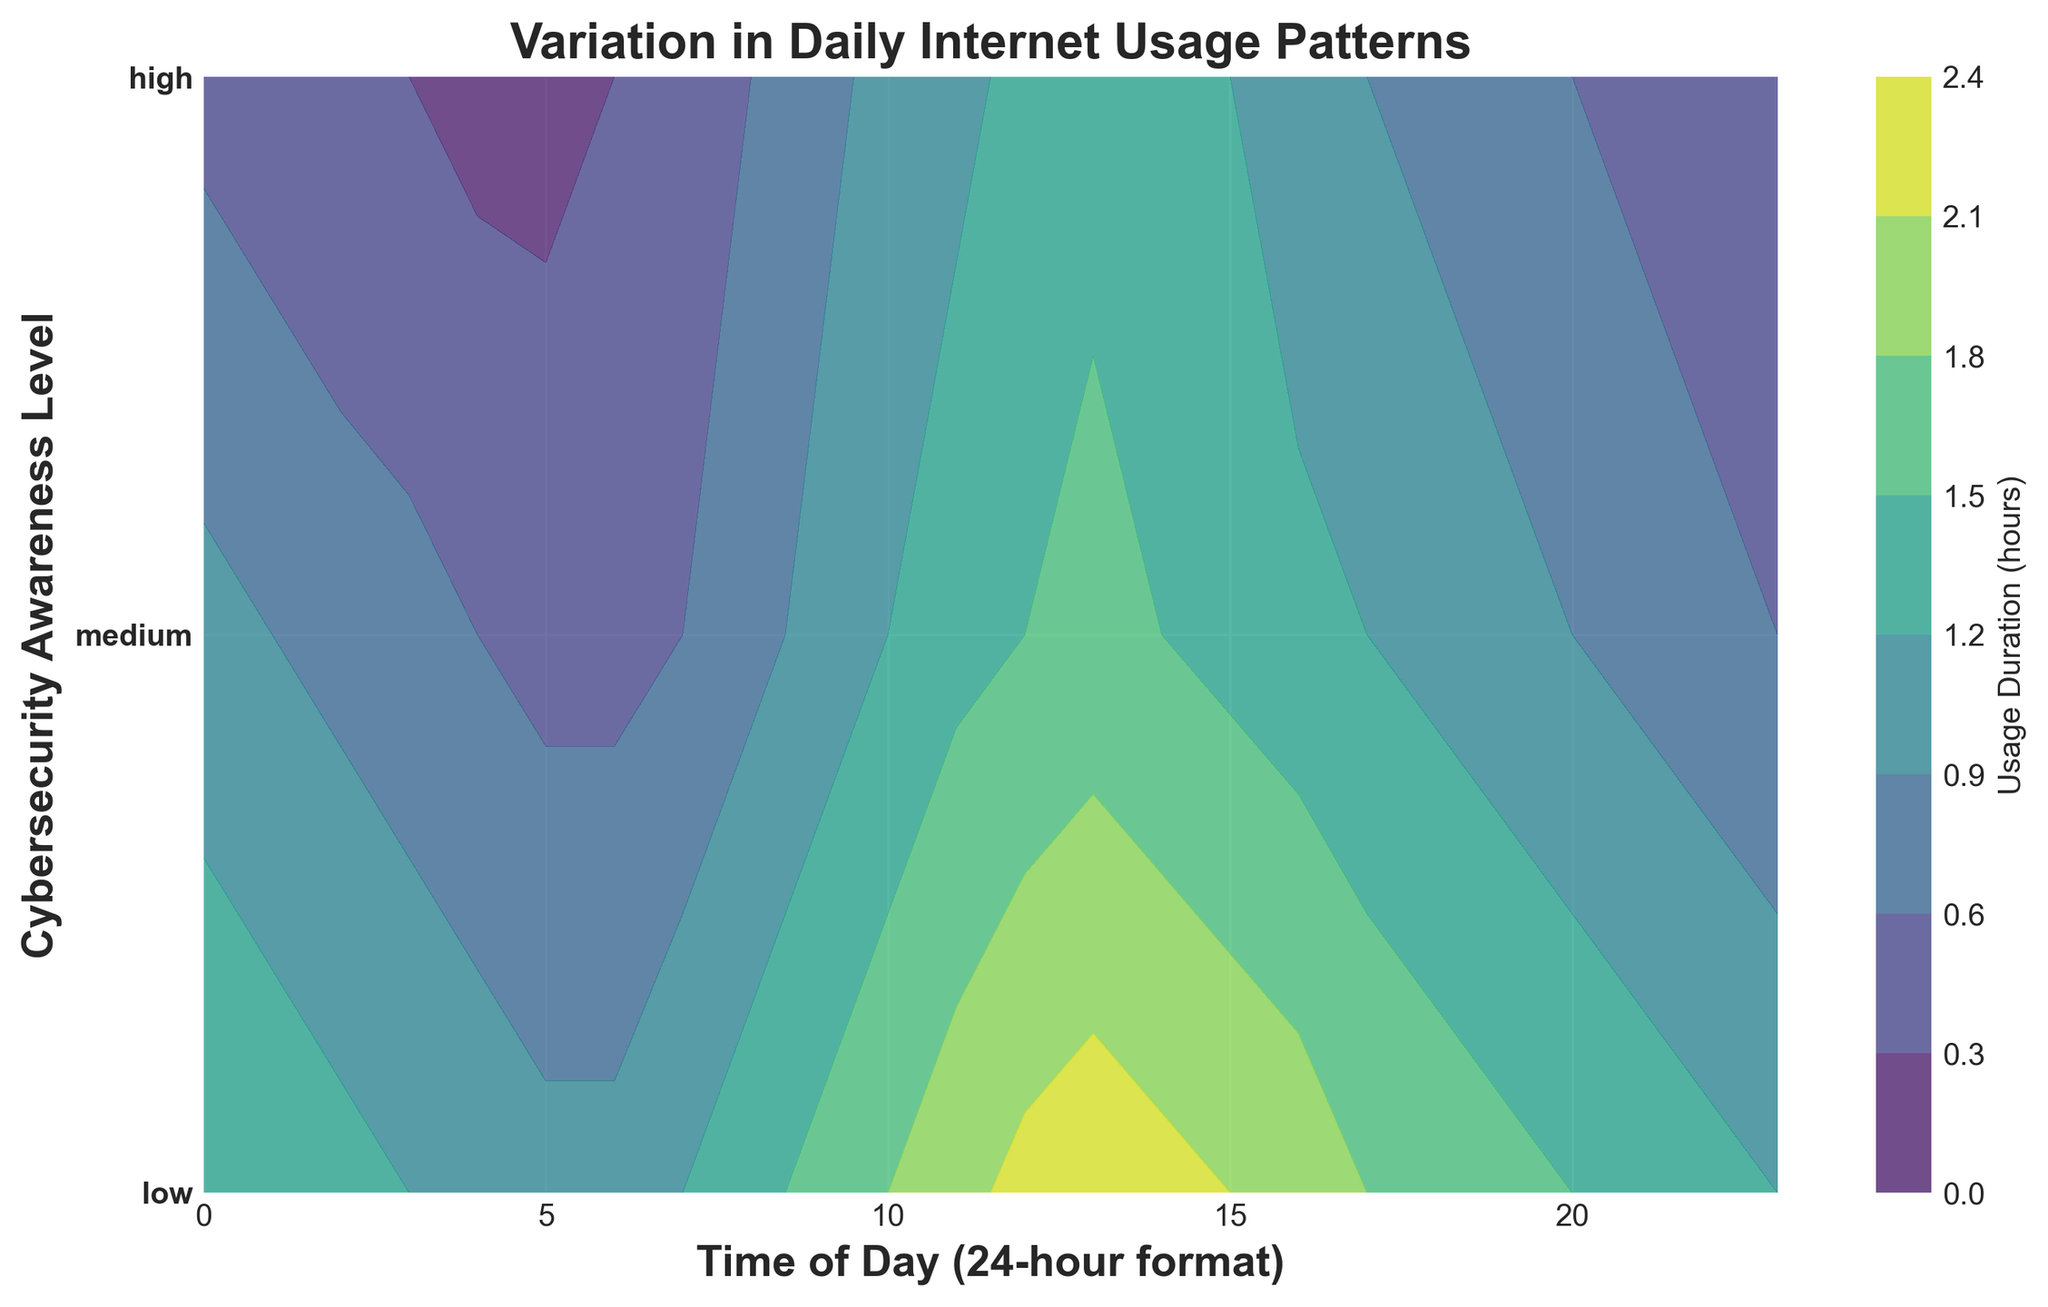Which cybersecurity awareness level shows the highest usage duration around noon? Looking at the peak usage duration around noon (12:00) on the y-axis, the high-awareness level shows around 1.3 hours, medium shows around 1.5 hours, and low shows around 2.2 hours. Thus, the low awareness level has the highest usage.
Answer: low During which time of day is the usage duration highest for the medium cybersecurity awareness level? For the medium awareness level, the usage duration is highest around noon (12:00) where it reaches 1.5 hours. This is seen by the darker color representing higher values around this time for the medium level in the contour plot.
Answer: 12:00 What is the significant difference in usage duration between low and high cybersecurity awareness levels around 10:00? At 10:00, the low awareness level shows around 1.8 hours of usage duration while the high level shows around 1 hour. The difference is calculated as 1.8 - 1 = 0.8 hours.
Answer: 0.8 hours Compare the peak usage durations of low and medium awareness levels. Which one is higher and by how much? The peak usage duration for the low awareness level is around 2.3 hours, observed around 13:00. For the medium level, the peak is around 1.5 hours at 12:00. The low level's peak is higher by 2.3 - 1.5 = 0.8 hours.
Answer: Low by 0.8 hours How does usage duration trend for high-awareness users from midnight to early morning? For high-awareness users, the usage duration starts at around 0.5 hours at midnight (0:00), decreases to 0.3 hours by 3:00, and then remains low at about 0.2 hours through to 6:00, indicating a decreasing trend through early morning.
Answer: Decreasing What can be said about the usage duration for medium awareness level users in the evening compared to the early morning? For medium awareness level users, the evening usage duration around 18:00 is around 1.1 hours, which is higher than the early morning (e.g., 3:00) usage duration of around 0.7 hours, indicating an increase toward the evening.
Answer: More in the evening Identify a time where the usage duration for low awareness level users starts to drop significantly in the afternoon. Around 17:00, the usage duration for low awareness level users starts dropping from 2 to 1.8 hours, indicating a significant decrease in the afternoon.
Answer: 17:00 What pattern is observed for low-awareness users' internet usage from noon to late afternoon? For low awareness users, the internet usage duration peaks at around 12:00-13:00 (2.2-2.3 hours) and then decreases gradually towards the late afternoon (16:00-18:00) where it nears around 1.7-1.8 hours.
Answer: Peaks and then decreases How does the duration of internet usage in the evening (20:00) compare between medium- and high-awareness levels? At 20:00, medium awareness level users have around 0.9 hours of usage while high awareness level users have around 0.6 hours. Medium-awareness users thus have a higher duration by 0.9 - 0.6 = 0.3 hours.
Answer: Medium by 0.3 hours What's the average usage duration at 8:00 for all awareness levels? At 8:00, the usage duration for low is 1.4 hours, medium is 0.8 hours, and high is 0.6 hours. The average is calculated as (1.4 + 0.8 + 0.6) / 3 = 0.93 hours.
Answer: 0.93 hours 